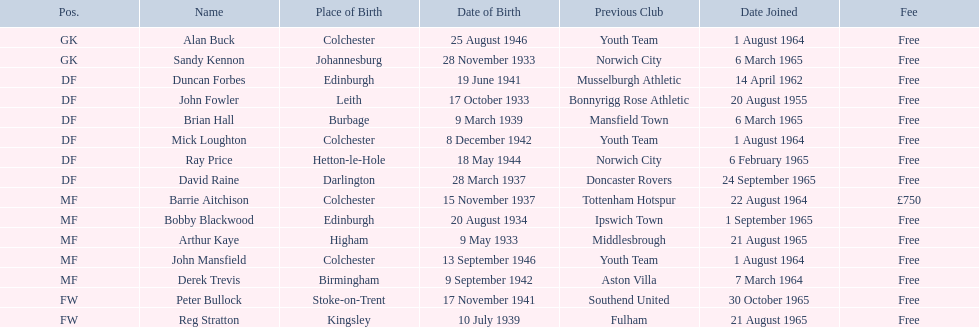When did alan buck join the colchester united f.c. in 1965-66? 1 August 1964. When did the last player to join? Peter Bullock. What date did the first player join? 20 August 1955. 